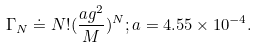<formula> <loc_0><loc_0><loc_500><loc_500>\Gamma _ { N } \doteq N ! ( \frac { a g ^ { 2 } } { M } ) ^ { N } ; a = 4 . 5 5 \times 1 0 ^ { - 4 } .</formula> 